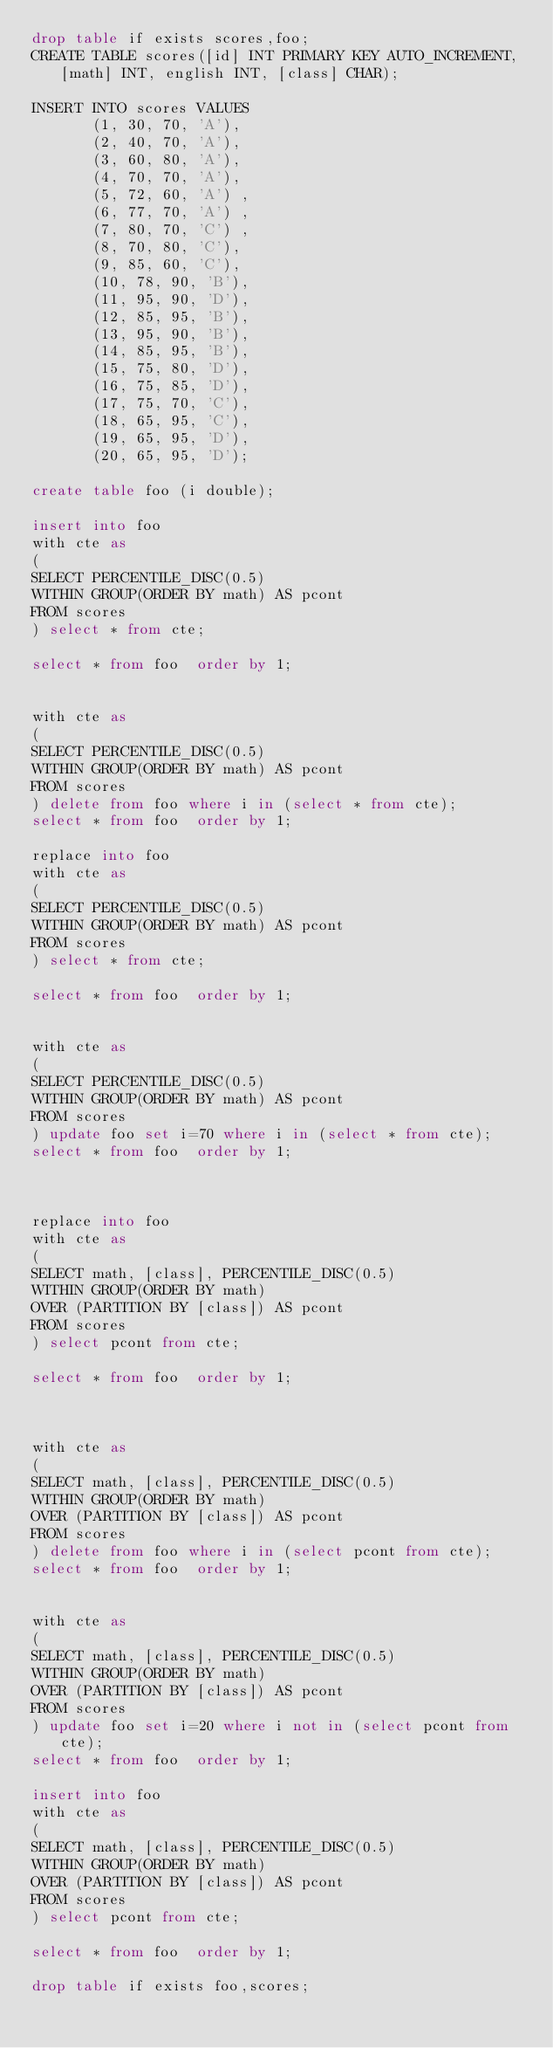<code> <loc_0><loc_0><loc_500><loc_500><_SQL_>drop table if exists scores,foo;
CREATE TABLE scores([id] INT PRIMARY KEY AUTO_INCREMENT, [math] INT, english INT, [class] CHAR);

INSERT INTO scores VALUES
       (1, 30, 70, 'A'),
       (2, 40, 70, 'A'),
       (3, 60, 80, 'A'),
       (4, 70, 70, 'A'),
       (5, 72, 60, 'A') ,
       (6, 77, 70, 'A') ,
       (7, 80, 70, 'C') ,
       (8, 70, 80, 'C'),
       (9, 85, 60, 'C'),
       (10, 78, 90, 'B'),
       (11, 95, 90, 'D'),
       (12, 85, 95, 'B'),
       (13, 95, 90, 'B'),
       (14, 85, 95, 'B'),
       (15, 75, 80, 'D'),
       (16, 75, 85, 'D'),
       (17, 75, 70, 'C'),
       (18, 65, 95, 'C'),
       (19, 65, 95, 'D'),
       (20, 65, 95, 'D');

create table foo (i double);

insert into foo
with cte as
(
SELECT PERCENTILE_DISC(0.5)
WITHIN GROUP(ORDER BY math) AS pcont
FROM scores
) select * from cte;

select * from foo  order by 1;


with cte as
(
SELECT PERCENTILE_DISC(0.5)
WITHIN GROUP(ORDER BY math) AS pcont
FROM scores
) delete from foo where i in (select * from cte);
select * from foo  order by 1;

replace into foo
with cte as
(
SELECT PERCENTILE_DISC(0.5)
WITHIN GROUP(ORDER BY math) AS pcont
FROM scores
) select * from cte;

select * from foo  order by 1;


with cte as
(
SELECT PERCENTILE_DISC(0.5)
WITHIN GROUP(ORDER BY math) AS pcont
FROM scores
) update foo set i=70 where i in (select * from cte);
select * from foo  order by 1;



replace into foo
with cte as
(
SELECT math, [class], PERCENTILE_DISC(0.5)
WITHIN GROUP(ORDER BY math)
OVER (PARTITION BY [class]) AS pcont
FROM scores
) select pcont from cte;

select * from foo  order by 1;



with cte as
(
SELECT math, [class], PERCENTILE_DISC(0.5)
WITHIN GROUP(ORDER BY math)
OVER (PARTITION BY [class]) AS pcont
FROM scores
) delete from foo where i in (select pcont from cte);
select * from foo  order by 1;


with cte as
(
SELECT math, [class], PERCENTILE_DISC(0.5)
WITHIN GROUP(ORDER BY math)
OVER (PARTITION BY [class]) AS pcont
FROM scores
) update foo set i=20 where i not in (select pcont from cte);
select * from foo  order by 1;

insert into foo
with cte as
(
SELECT math, [class], PERCENTILE_DISC(0.5)
WITHIN GROUP(ORDER BY math)
OVER (PARTITION BY [class]) AS pcont
FROM scores
) select pcont from cte;

select * from foo  order by 1;

drop table if exists foo,scores;
</code> 